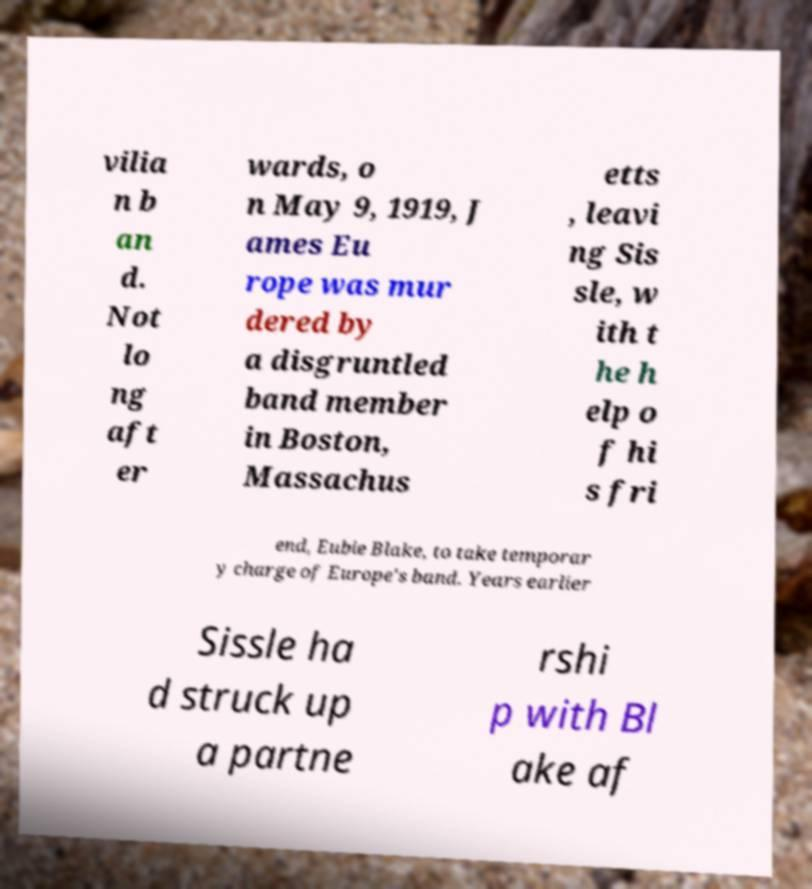Can you read and provide the text displayed in the image?This photo seems to have some interesting text. Can you extract and type it out for me? vilia n b an d. Not lo ng aft er wards, o n May 9, 1919, J ames Eu rope was mur dered by a disgruntled band member in Boston, Massachus etts , leavi ng Sis sle, w ith t he h elp o f hi s fri end, Eubie Blake, to take temporar y charge of Europe's band. Years earlier Sissle ha d struck up a partne rshi p with Bl ake af 